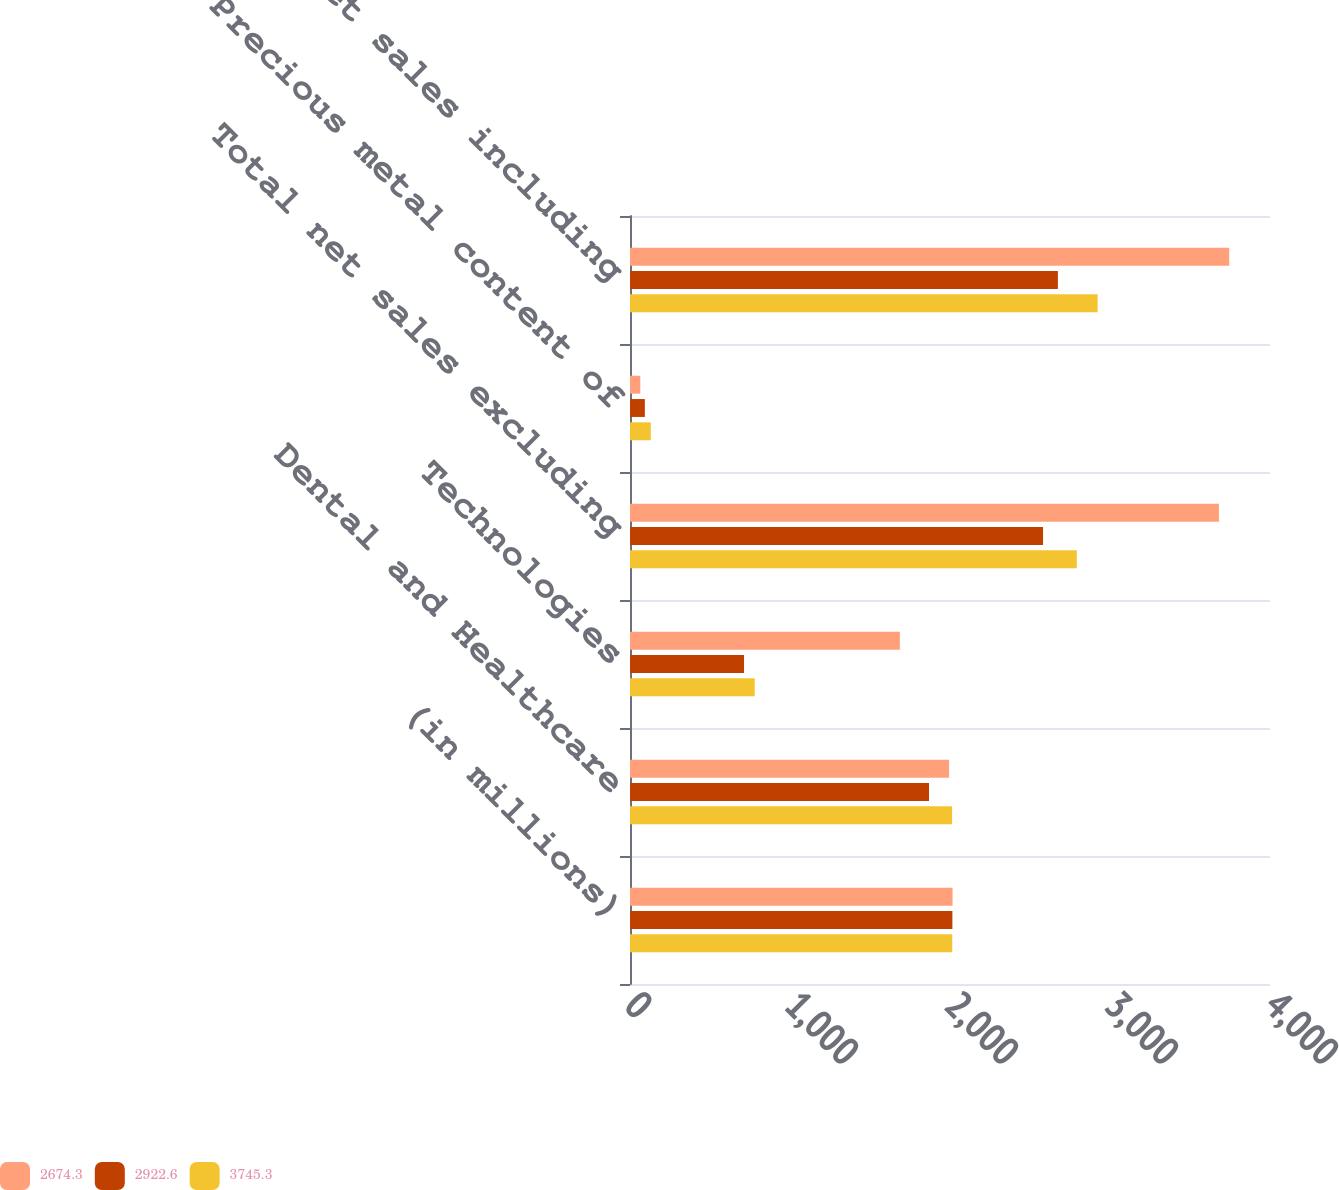Convert chart. <chart><loc_0><loc_0><loc_500><loc_500><stacked_bar_chart><ecel><fcel>(in millions)<fcel>Dental and Healthcare<fcel>Technologies<fcel>Total net sales excluding<fcel>Precious metal content of<fcel>Total net sales including<nl><fcel>2674.3<fcel>2016<fcel>1994.3<fcel>1686.7<fcel>3681<fcel>64.3<fcel>3745.3<nl><fcel>2922.6<fcel>2015<fcel>1868.8<fcel>712.7<fcel>2581.5<fcel>92.8<fcel>2674.3<nl><fcel>3745.3<fcel>2014<fcel>2013.2<fcel>779.5<fcel>2792.7<fcel>129.9<fcel>2922.6<nl></chart> 